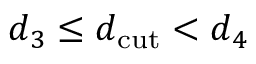<formula> <loc_0><loc_0><loc_500><loc_500>d _ { 3 } \leq d _ { c u t } < d _ { 4 }</formula> 